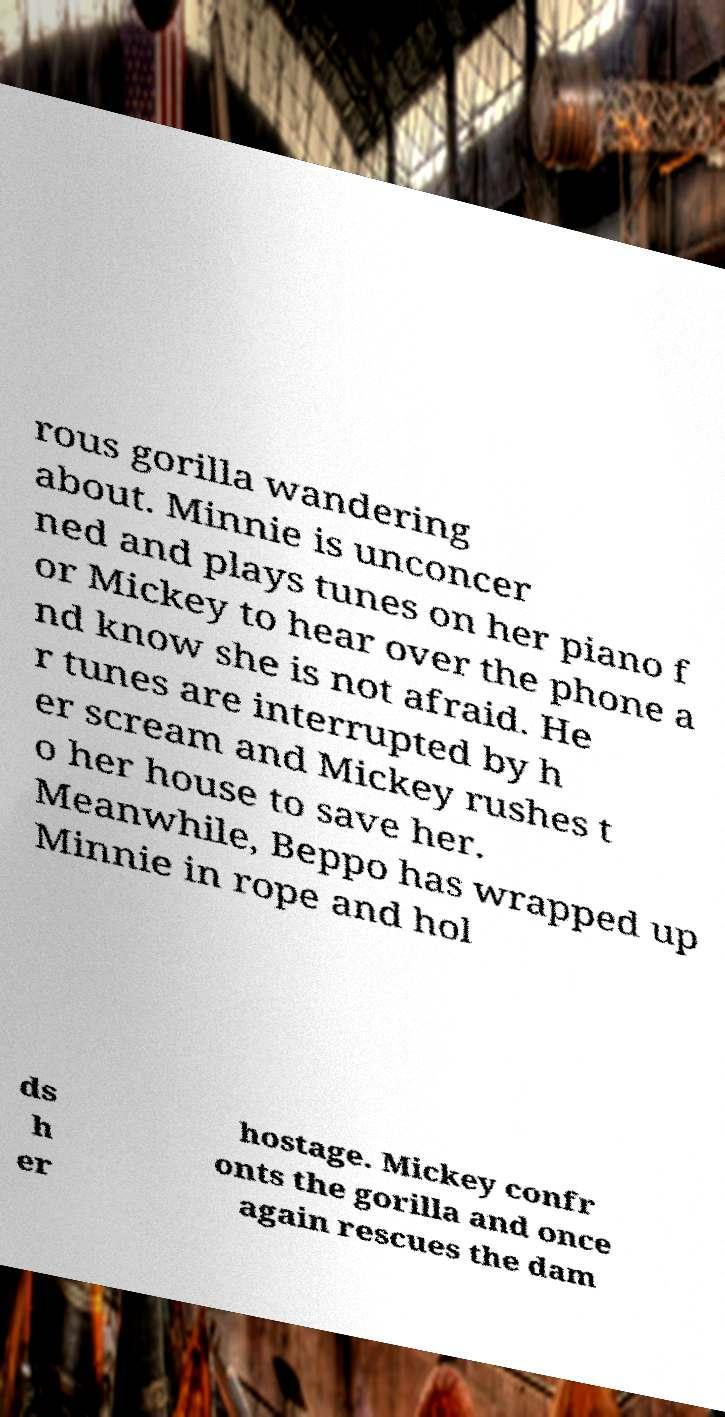Can you accurately transcribe the text from the provided image for me? rous gorilla wandering about. Minnie is unconcer ned and plays tunes on her piano f or Mickey to hear over the phone a nd know she is not afraid. He r tunes are interrupted by h er scream and Mickey rushes t o her house to save her. Meanwhile, Beppo has wrapped up Minnie in rope and hol ds h er hostage. Mickey confr onts the gorilla and once again rescues the dam 